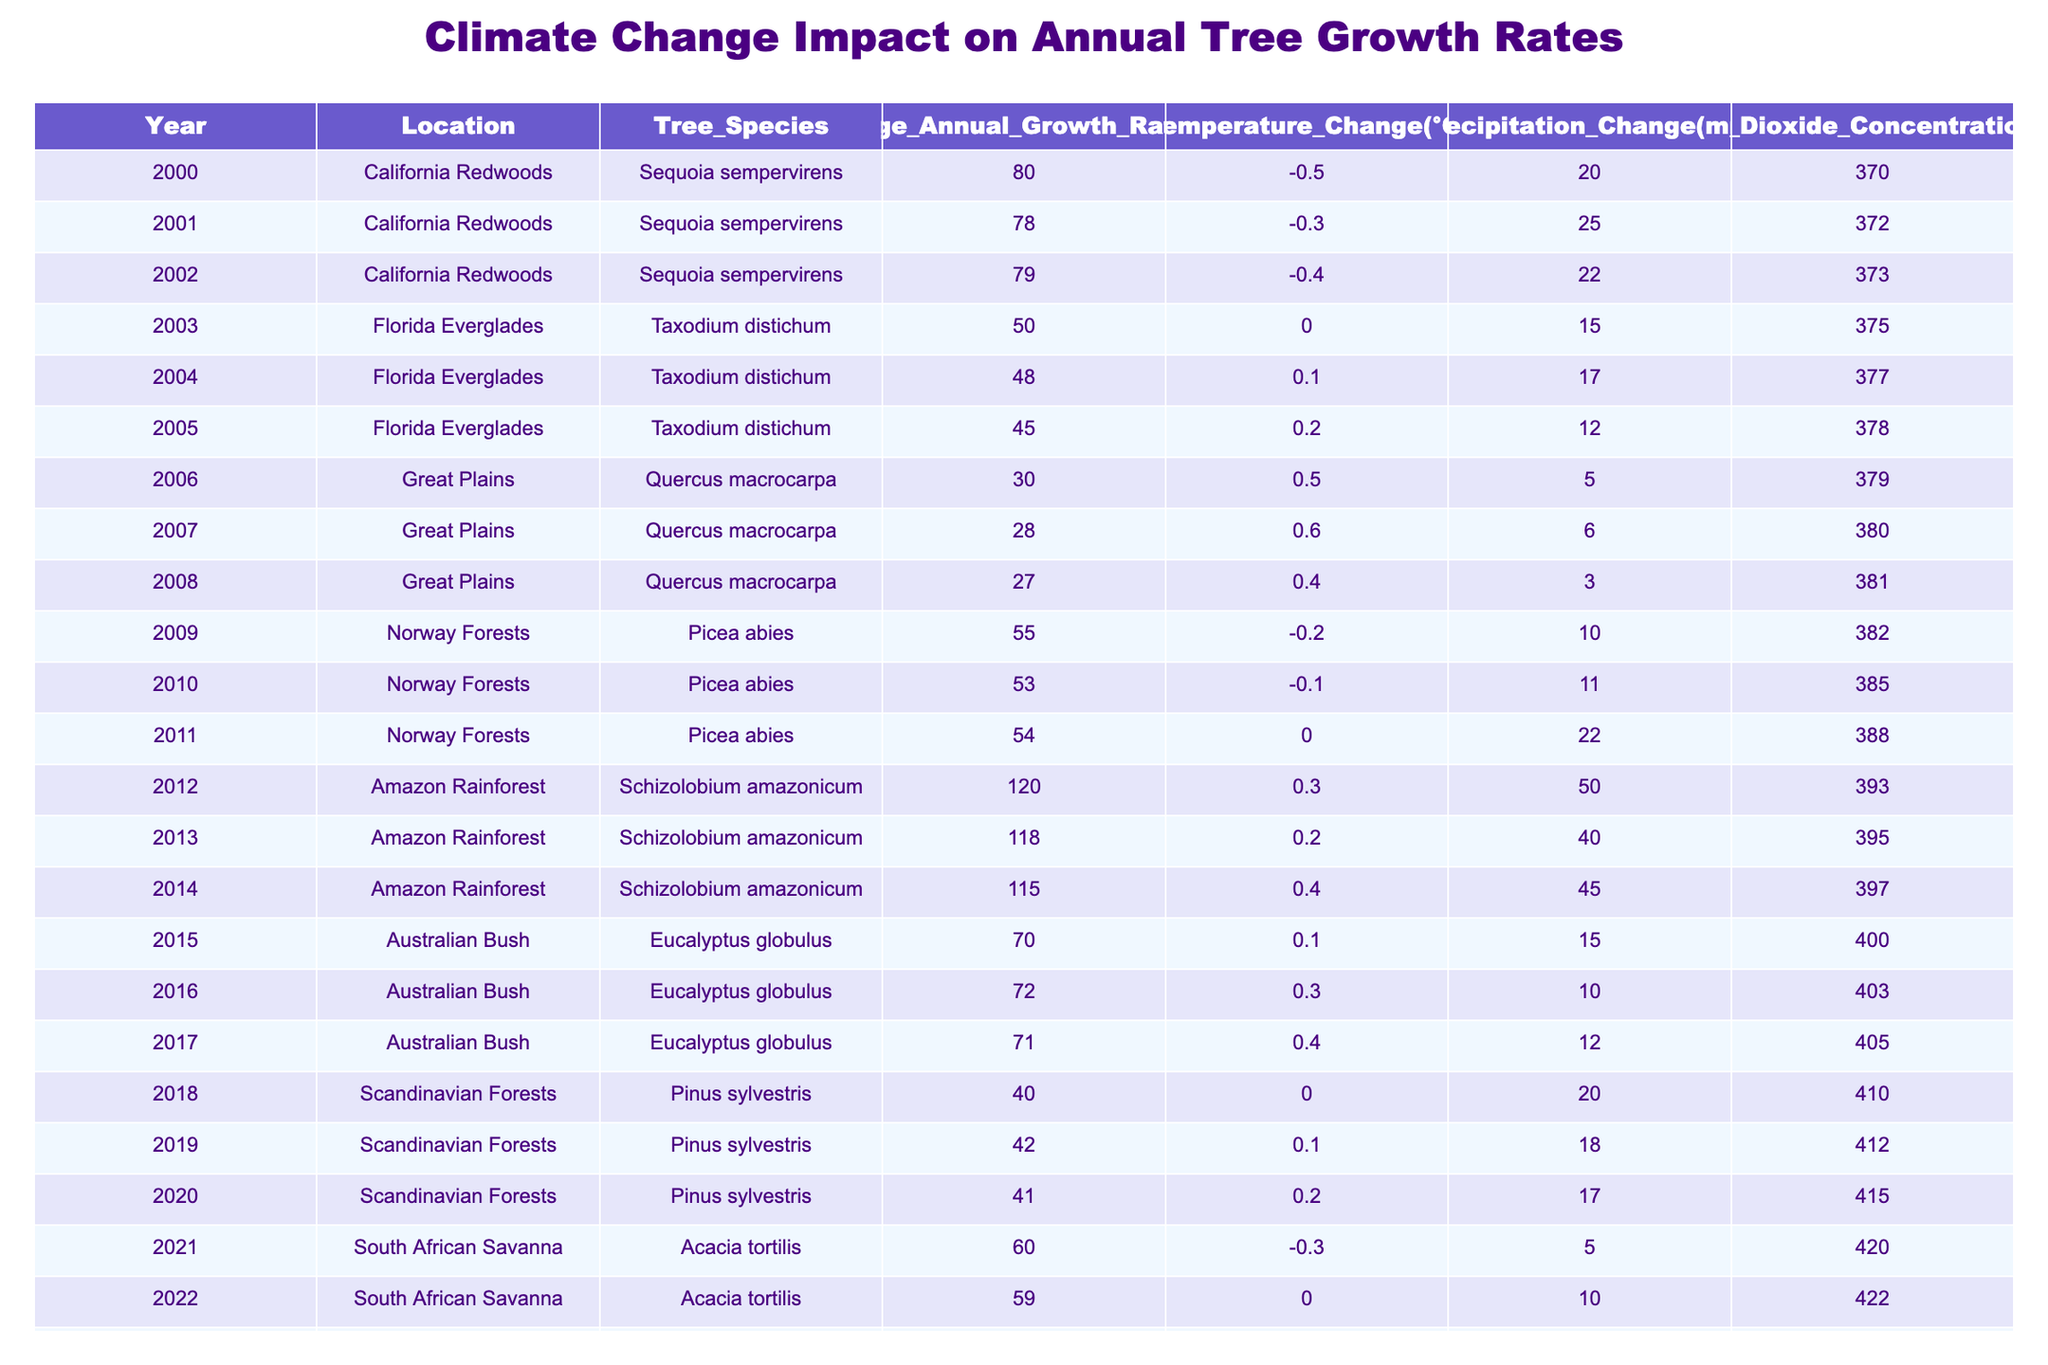What was the average annual growth rate for Sequoia sempervirens from 2000 to 2002? To find the average, sum the annual growth rates: 80 (2000) + 78 (2001) + 79 (2002) = 237. There are 3 years, so the average is 237/3 = 79.
Answer: 79 Which tree species had the highest average annual growth rate in the dataset? The average growth rates for the species are as follows: Sequoia sempervirens: (80 + 78 + 79) / 3 = 79, Taxodium distichum: (50 + 48 + 45) / 3 = 47.67, Quercus macrocarpa: (30 + 28 + 27) / 3 = 28.33, Picea abies: (55 + 53 + 54) / 3 = 54, Schizolobium amazonicum: (120 + 118 + 115) / 3 = 117.67, Eucalyptus globulus: (70 + 72 + 71) / 3 = 71, Pinus sylvestris: (40 + 42 + 41) / 3 = 41, Acacia tortilis: (60 + 59 + 58) / 3 = 59. The highest average growth rate is for Schizolobium amazonicum.
Answer: Schizolobium amazonicum Did the average annual growth rate for the Scandinavian Forests increase from 2018 to 2020? The average annual growth rates are: 40 (2018), 42 (2019), and 41 (2020). Comparing the values, the growth rate increased from 40 to 42, then decreased to 41, so it did not consistently increase.
Answer: No What was the total precipitation change across all years for the Florida Everglades? The precipitation changes for Florida Everglades are: 15 (2003) + 17 (2004) + 12 (2005) = 44 mm.
Answer: 44 mm In which year did the Amazon Rainforest record the highest annual growth rate, and what was that rate? By reviewing the growth rates for Schizolobium amazonicum: 120 (2012), 118 (2013), 115 (2014). The highest recorded growth rate was in 2012 at 120 cm.
Answer: 2012, 120 cm What is the trend in temperature change for the South African Savanna from 2021 to 2023? The temperature changes are: -0.3 (2021), 0.0 (2022), and 0.1 (2023). The temperatures went from a decrease to no change, and a slight increase, indicating an upward trend overall.
Answer: Upward trend What was the percentage decrease in the average annual growth rate for Taxodium distichum from 2003 to 2005? The growth rates are 50 (2003), 48 (2004), and 45 (2005). The decrease from 50 in 2003 to 45 in 2005 is 50 - 45 = 5. The percentage decrease is (5/50) * 100 = 10%.
Answer: 10% Which location experienced the largest carbon dioxide concentration increase from 2000 to 2023? Assessing the CO2 concentrations: California Redwoods (370 to 372) = +2, Florida Everglades (375 to 378) = +3, Great Plains (379 to 381) = +2, Norway Forests (382 to 388) = +6, Amazon Rainforest (393 to 397) = +4, Australian Bush (400 to 405) = +5, Scandinavian Forests (410 to 415) = +5, South African Savanna (420 to 425) = +5. The largest increase is +6 in Norway Forests.
Answer: Norway Forests, +6 ppm 